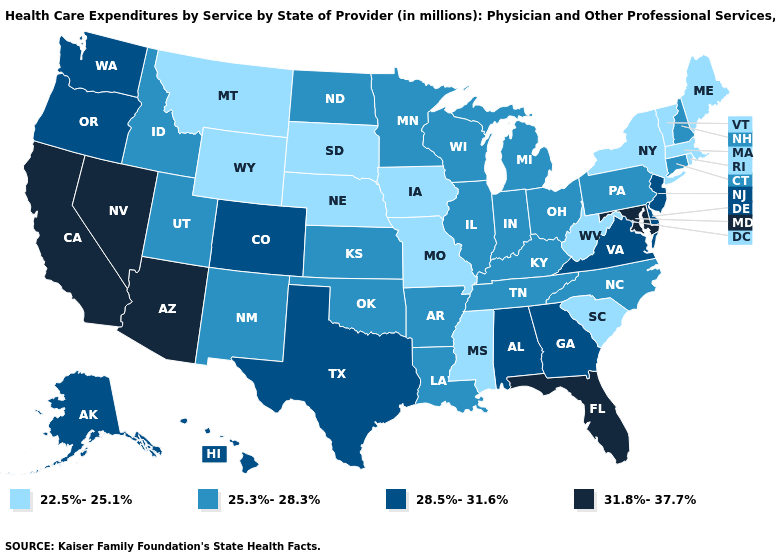Is the legend a continuous bar?
Give a very brief answer. No. What is the lowest value in the Northeast?
Keep it brief. 22.5%-25.1%. Does Massachusetts have a lower value than New York?
Short answer required. No. Does California have the lowest value in the USA?
Short answer required. No. Is the legend a continuous bar?
Concise answer only. No. Is the legend a continuous bar?
Keep it brief. No. Name the states that have a value in the range 25.3%-28.3%?
Quick response, please. Arkansas, Connecticut, Idaho, Illinois, Indiana, Kansas, Kentucky, Louisiana, Michigan, Minnesota, New Hampshire, New Mexico, North Carolina, North Dakota, Ohio, Oklahoma, Pennsylvania, Tennessee, Utah, Wisconsin. What is the highest value in the USA?
Concise answer only. 31.8%-37.7%. Among the states that border New York , does New Jersey have the highest value?
Concise answer only. Yes. What is the lowest value in the South?
Write a very short answer. 22.5%-25.1%. Name the states that have a value in the range 31.8%-37.7%?
Concise answer only. Arizona, California, Florida, Maryland, Nevada. Does Wisconsin have a lower value than New York?
Quick response, please. No. How many symbols are there in the legend?
Short answer required. 4. Name the states that have a value in the range 31.8%-37.7%?
Write a very short answer. Arizona, California, Florida, Maryland, Nevada. 